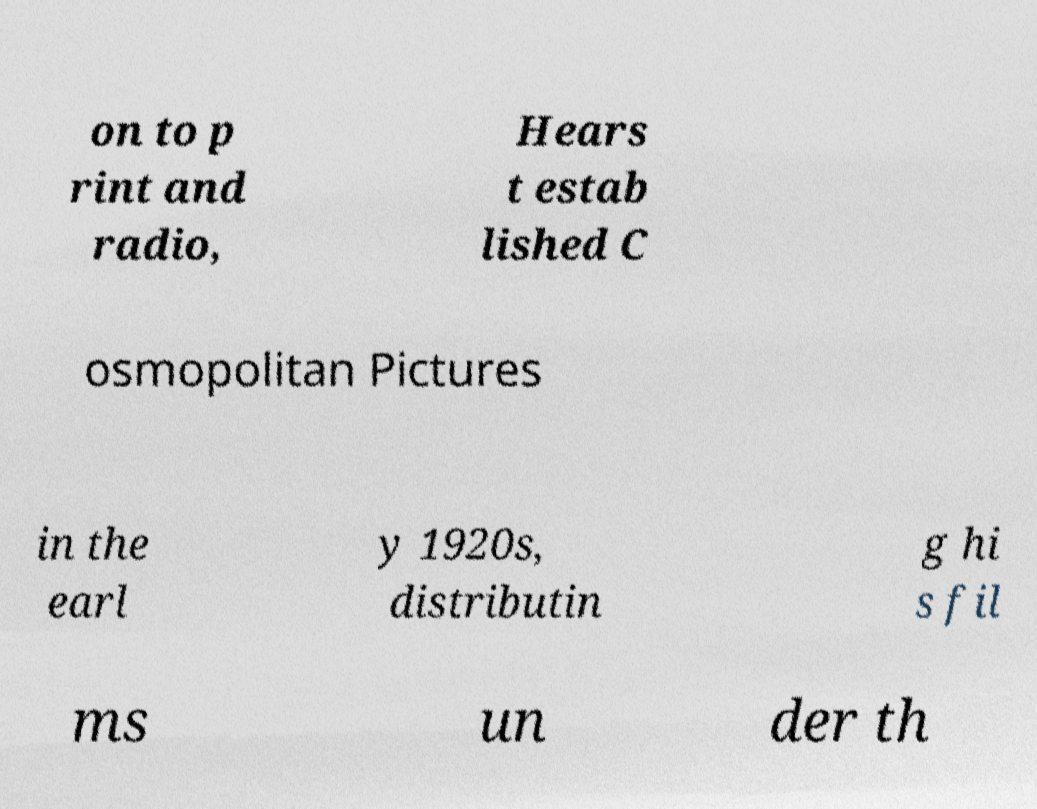Can you accurately transcribe the text from the provided image for me? on to p rint and radio, Hears t estab lished C osmopolitan Pictures in the earl y 1920s, distributin g hi s fil ms un der th 